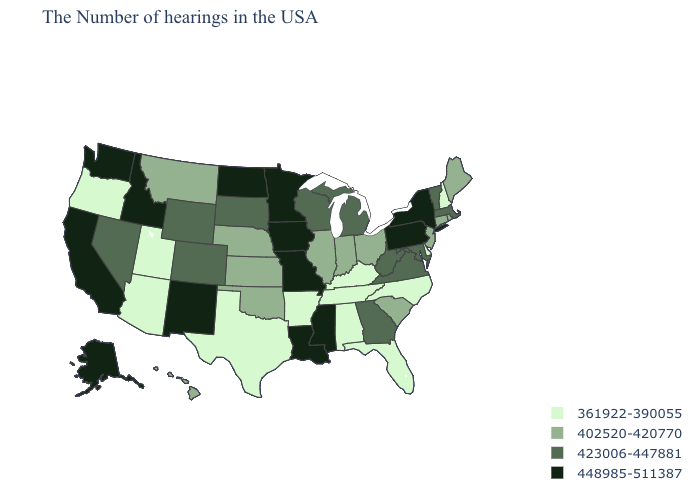Does the map have missing data?
Quick response, please. No. What is the value of Florida?
Short answer required. 361922-390055. Among the states that border Missouri , which have the lowest value?
Quick response, please. Kentucky, Tennessee, Arkansas. What is the value of California?
Short answer required. 448985-511387. What is the value of Wisconsin?
Give a very brief answer. 423006-447881. Among the states that border Arkansas , does Oklahoma have the highest value?
Be succinct. No. Which states have the lowest value in the West?
Be succinct. Utah, Arizona, Oregon. Among the states that border Tennessee , which have the lowest value?
Concise answer only. North Carolina, Kentucky, Alabama, Arkansas. What is the value of Montana?
Answer briefly. 402520-420770. Does New Mexico have a higher value than North Dakota?
Keep it brief. No. What is the value of Idaho?
Write a very short answer. 448985-511387. How many symbols are there in the legend?
Keep it brief. 4. Among the states that border Colorado , which have the highest value?
Be succinct. New Mexico. Name the states that have a value in the range 361922-390055?
Write a very short answer. New Hampshire, Delaware, North Carolina, Florida, Kentucky, Alabama, Tennessee, Arkansas, Texas, Utah, Arizona, Oregon. 